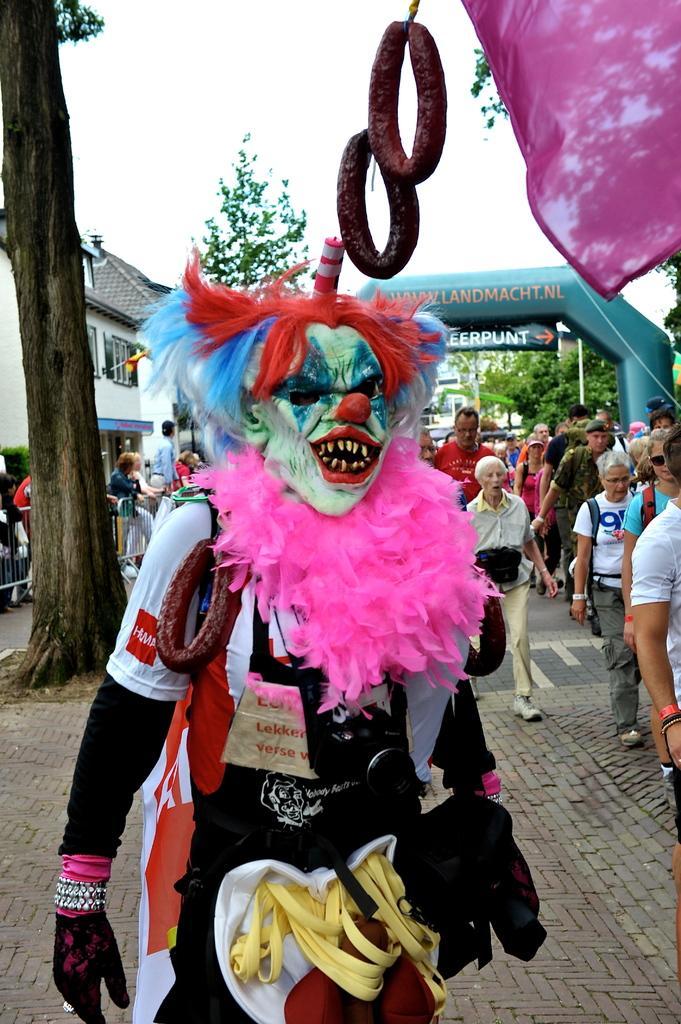How would you summarize this image in a sentence or two? In this image there is a man wearing costumes and standing on a pavement, in the background there are people standing and there are trees houses and an arch. 